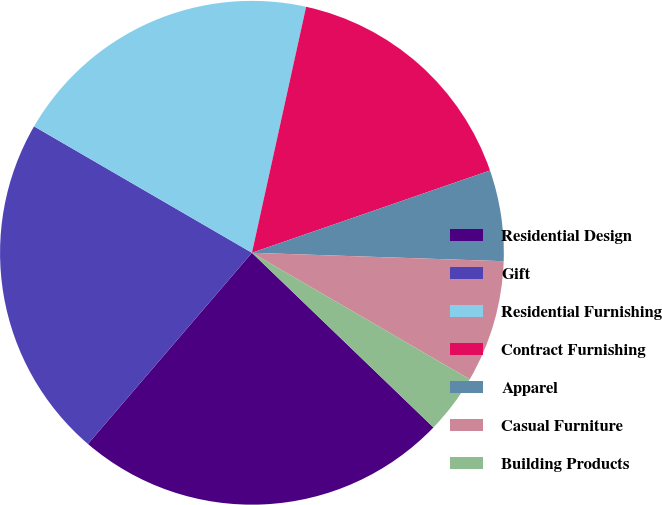<chart> <loc_0><loc_0><loc_500><loc_500><pie_chart><fcel>Residential Design<fcel>Gift<fcel>Residential Furnishing<fcel>Contract Furnishing<fcel>Apparel<fcel>Casual Furniture<fcel>Building Products<nl><fcel>24.09%<fcel>22.08%<fcel>20.08%<fcel>16.25%<fcel>5.83%<fcel>7.84%<fcel>3.82%<nl></chart> 